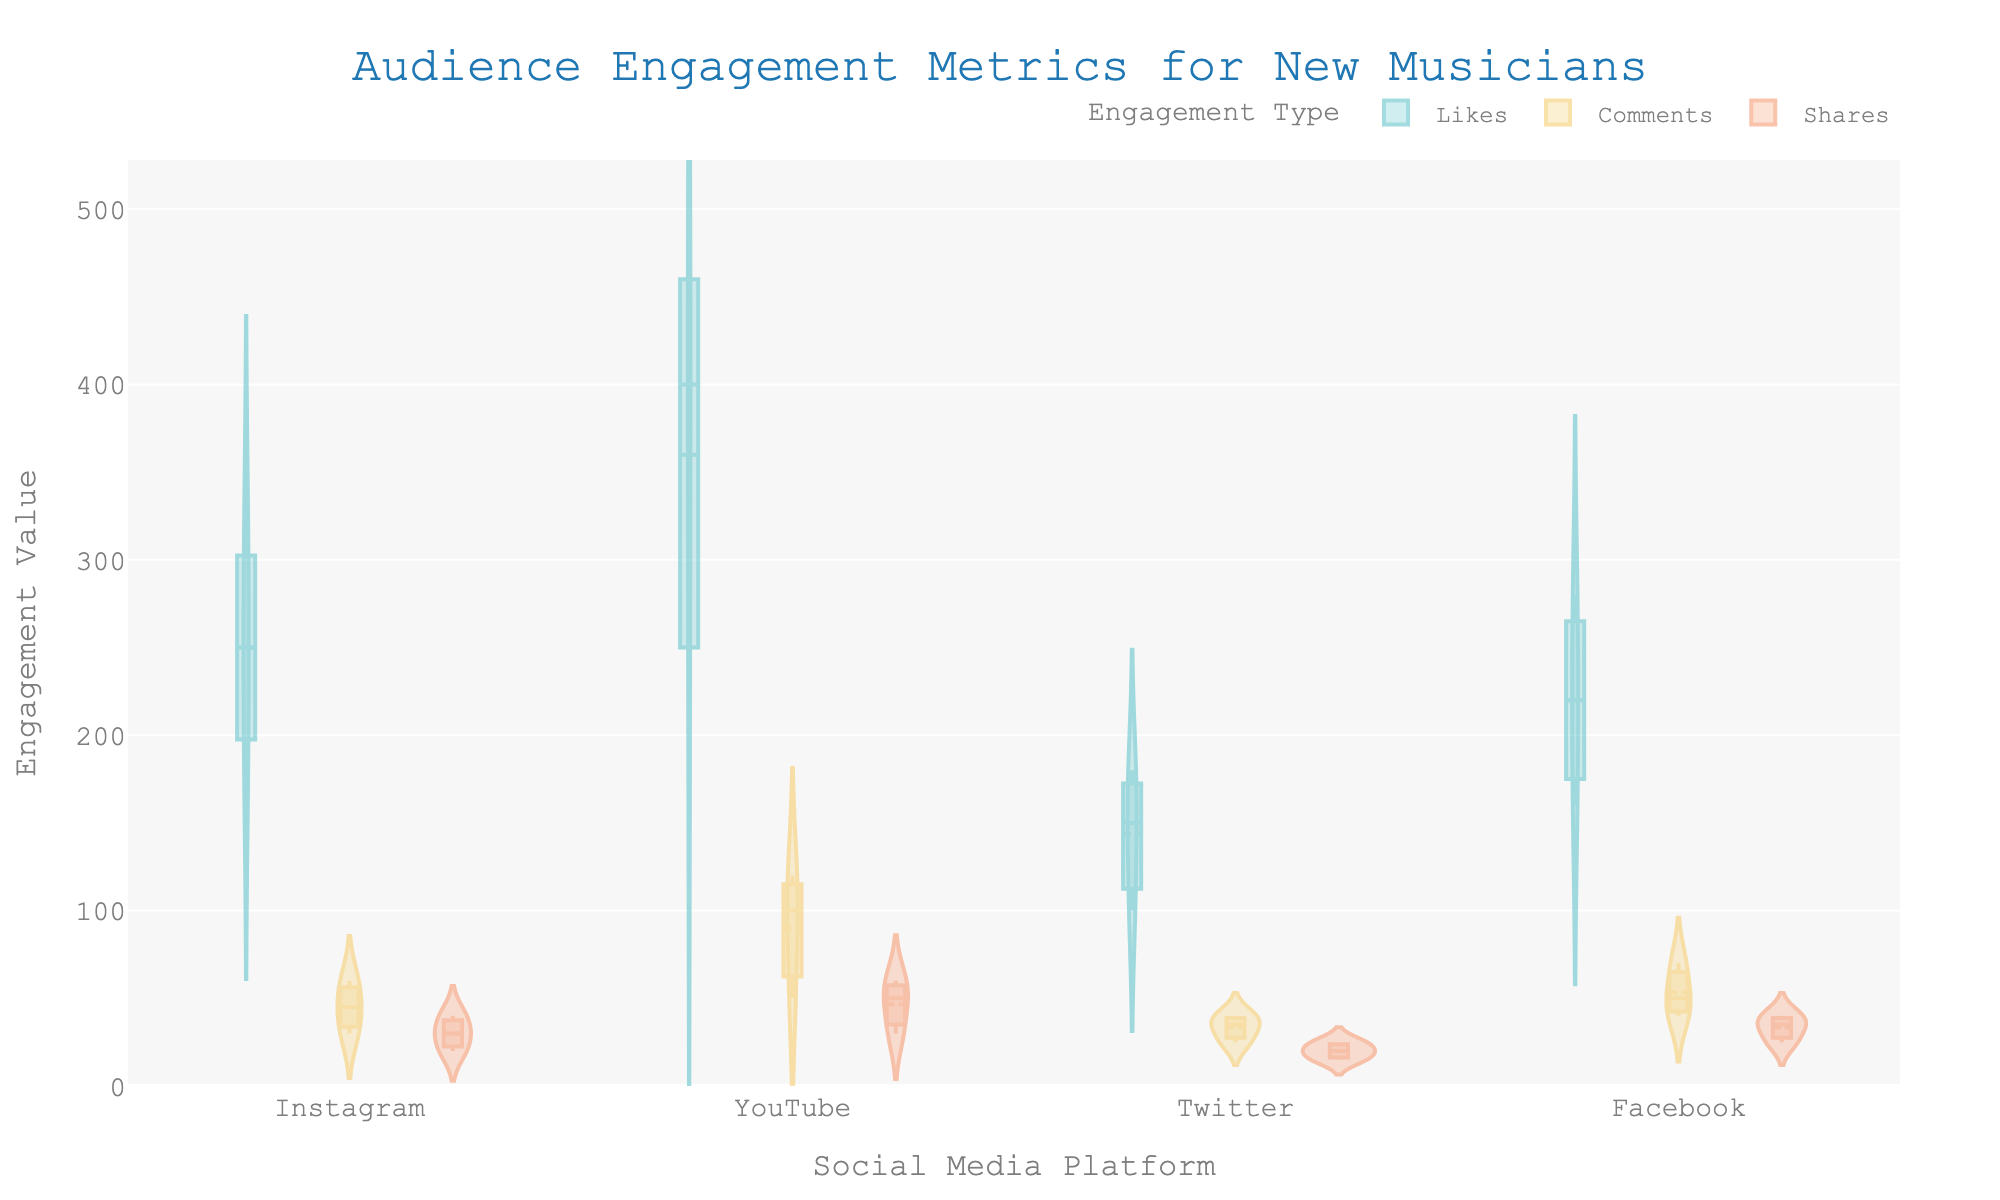What is the title of the chart? The title of the chart is displayed at the top, indicating the main subject of the visualization.
Answer: Audience Engagement Metrics for New Musicians How many social media platforms are compared in the chart? Social media platforms are represented along the horizontal axis (x-axis) where each platform's name is listed. Count the number of distinct platform names.
Answer: 4 Which engagement type has the highest metric value on YouTube? Identify the highest point on the violin plot for YouTube and determine which engagement type (color) it represents.
Answer: Likes What is the median value for likes on Instagram? The median value is represented by a horizontal line inside the box plot of the violin for likes on Instagram. Inspect the plot's box representation for accuracy.
Answer: 250 Which artist has the lowest metric value for Twitter shares? Look at the individual points (jittered points) for the shares on Twitter and note the lowest point; then identify the artist associated with this point.
Answer: BellaHendry Compare the average likes among all artists on Facebook with those on Instagram. Which platform has a higher average? Calculate the average likes for Facebook and Instagram by summing the likes for each artist and dividing by the number of artists. Facebook has 220+280+160/3 = 220 and Instagram has 250+320+180/3 = 250. Compare these averages to answer.
Answer: Instagram Which platform shows the most variation in comments? The variation in comments is visualized by the width and spread of the violin plots for the comments category. Identify the platform with the widest spread in comments' violin plots.
Answer: YouTube What is the range of values for shares on Facebook? The range is the difference between the maximum and minimum values for shares on Facebook. Locate the highest and lowest points for Facebook shares on the vertical axis (y-axis). The range is from 25 to 40, so 40 - 25 = 15.
Answer: 15 How do the engagement metrics for BellaHendry on YouTube compare with those on Twitter? Compare the individual points representing BellaHendry for likes, comments, and shares on YouTube against those on Twitter by noting their positions on the y-axis. BellaHendry has higher engagement on YouTube for all metrics compared to Twitter.
Answer: Higher on YouTube 